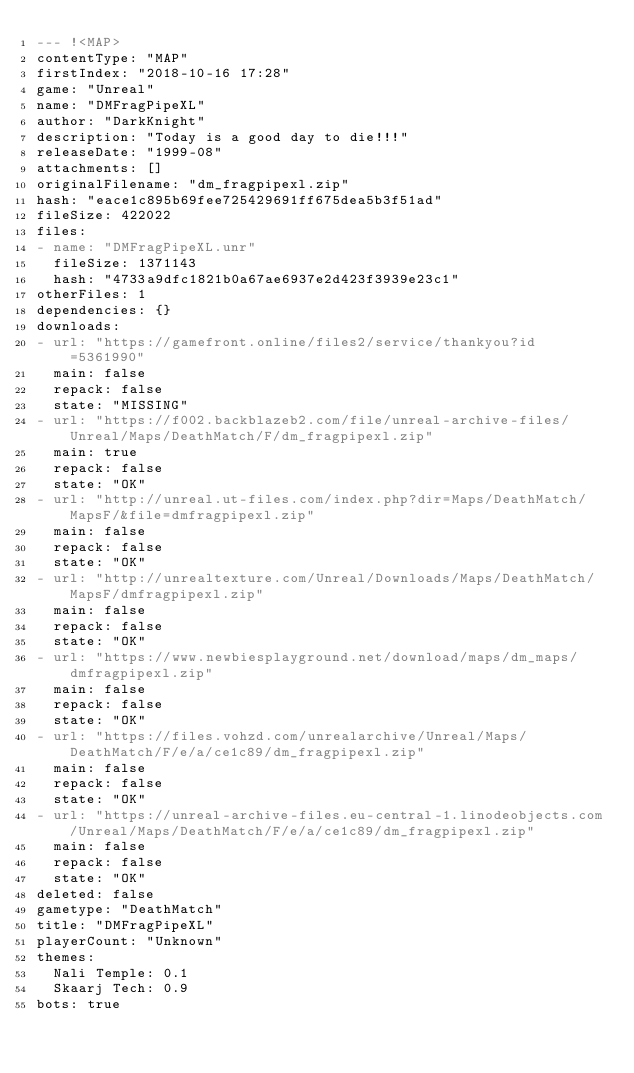<code> <loc_0><loc_0><loc_500><loc_500><_YAML_>--- !<MAP>
contentType: "MAP"
firstIndex: "2018-10-16 17:28"
game: "Unreal"
name: "DMFragPipeXL"
author: "DarkKnight"
description: "Today is a good day to die!!!"
releaseDate: "1999-08"
attachments: []
originalFilename: "dm_fragpipexl.zip"
hash: "eace1c895b69fee725429691ff675dea5b3f51ad"
fileSize: 422022
files:
- name: "DMFragPipeXL.unr"
  fileSize: 1371143
  hash: "4733a9dfc1821b0a67ae6937e2d423f3939e23c1"
otherFiles: 1
dependencies: {}
downloads:
- url: "https://gamefront.online/files2/service/thankyou?id=5361990"
  main: false
  repack: false
  state: "MISSING"
- url: "https://f002.backblazeb2.com/file/unreal-archive-files/Unreal/Maps/DeathMatch/F/dm_fragpipexl.zip"
  main: true
  repack: false
  state: "OK"
- url: "http://unreal.ut-files.com/index.php?dir=Maps/DeathMatch/MapsF/&file=dmfragpipexl.zip"
  main: false
  repack: false
  state: "OK"
- url: "http://unrealtexture.com/Unreal/Downloads/Maps/DeathMatch/MapsF/dmfragpipexl.zip"
  main: false
  repack: false
  state: "OK"
- url: "https://www.newbiesplayground.net/download/maps/dm_maps/dmfragpipexl.zip"
  main: false
  repack: false
  state: "OK"
- url: "https://files.vohzd.com/unrealarchive/Unreal/Maps/DeathMatch/F/e/a/ce1c89/dm_fragpipexl.zip"
  main: false
  repack: false
  state: "OK"
- url: "https://unreal-archive-files.eu-central-1.linodeobjects.com/Unreal/Maps/DeathMatch/F/e/a/ce1c89/dm_fragpipexl.zip"
  main: false
  repack: false
  state: "OK"
deleted: false
gametype: "DeathMatch"
title: "DMFragPipeXL"
playerCount: "Unknown"
themes:
  Nali Temple: 0.1
  Skaarj Tech: 0.9
bots: true
</code> 